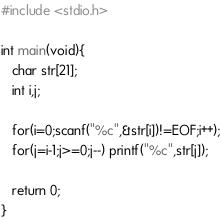Convert code to text. <code><loc_0><loc_0><loc_500><loc_500><_C_>#include <stdio.h>

int main(void){
   char str[21];
   int i,j;
   
   for(i=0;scanf("%c",&str[i])!=EOF;i++);
   for(j=i-1;j>=0;j--) printf("%c",str[j]);
   
   return 0;
}

</code> 